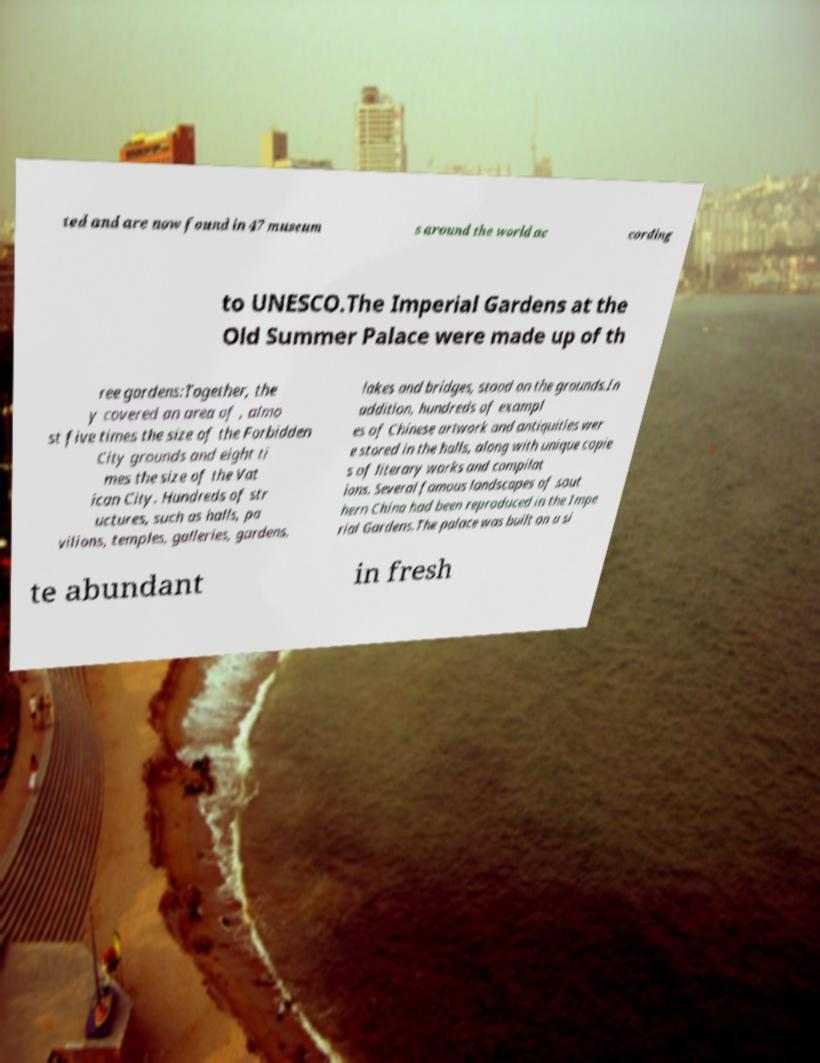Could you extract and type out the text from this image? ted and are now found in 47 museum s around the world ac cording to UNESCO.The Imperial Gardens at the Old Summer Palace were made up of th ree gardens:Together, the y covered an area of , almo st five times the size of the Forbidden City grounds and eight ti mes the size of the Vat ican City. Hundreds of str uctures, such as halls, pa vilions, temples, galleries, gardens, lakes and bridges, stood on the grounds.In addition, hundreds of exampl es of Chinese artwork and antiquities wer e stored in the halls, along with unique copie s of literary works and compilat ions. Several famous landscapes of sout hern China had been reproduced in the Impe rial Gardens.The palace was built on a si te abundant in fresh 